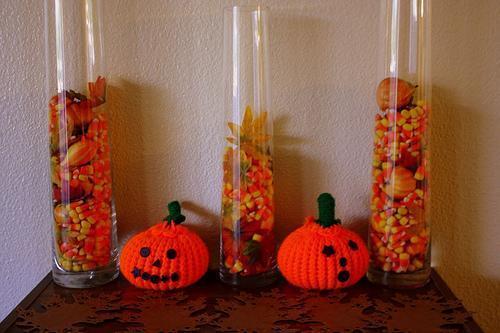How many black fruit are there?
Give a very brief answer. 0. 